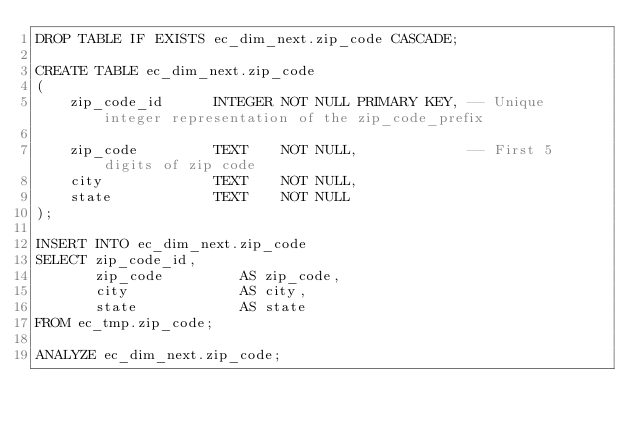<code> <loc_0><loc_0><loc_500><loc_500><_SQL_>DROP TABLE IF EXISTS ec_dim_next.zip_code CASCADE;

CREATE TABLE ec_dim_next.zip_code
(
    zip_code_id      INTEGER NOT NULL PRIMARY KEY, -- Unique integer representation of the zip_code_prefix

    zip_code         TEXT    NOT NULL,             -- First 5 digits of zip code
    city             TEXT    NOT NULL,
    state            TEXT    NOT NULL
);

INSERT INTO ec_dim_next.zip_code
SELECT zip_code_id,
       zip_code         AS zip_code,
       city             AS city,
       state            AS state
FROM ec_tmp.zip_code;

ANALYZE ec_dim_next.zip_code;
</code> 